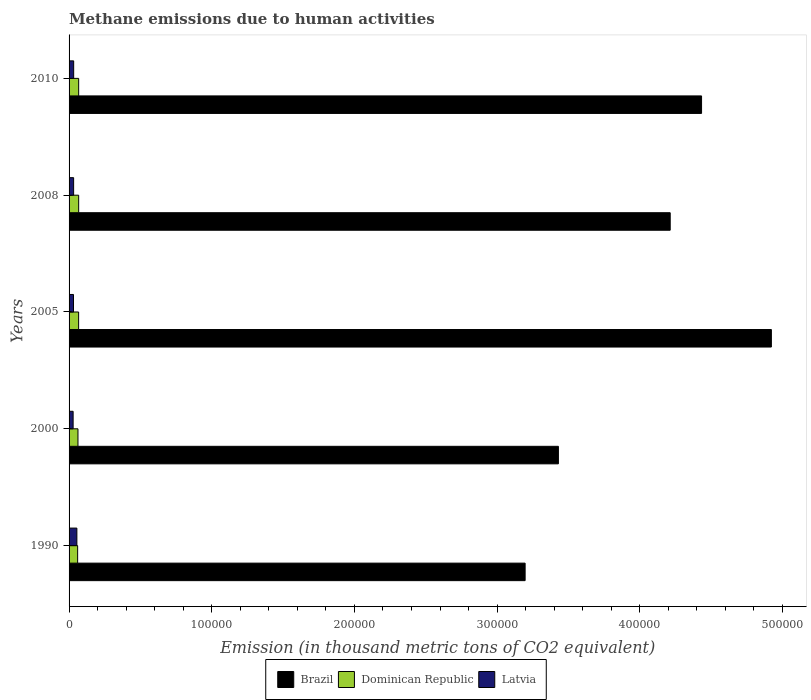Are the number of bars per tick equal to the number of legend labels?
Your answer should be very brief. Yes. What is the amount of methane emitted in Latvia in 2000?
Your response must be concise. 2840. Across all years, what is the maximum amount of methane emitted in Latvia?
Give a very brief answer. 5472.8. Across all years, what is the minimum amount of methane emitted in Brazil?
Ensure brevity in your answer.  3.20e+05. In which year was the amount of methane emitted in Dominican Republic minimum?
Provide a succinct answer. 1990. What is the total amount of methane emitted in Brazil in the graph?
Your response must be concise. 2.02e+06. What is the difference between the amount of methane emitted in Dominican Republic in 2000 and that in 2005?
Give a very brief answer. -456. What is the difference between the amount of methane emitted in Brazil in 1990 and the amount of methane emitted in Dominican Republic in 2008?
Your response must be concise. 3.13e+05. What is the average amount of methane emitted in Dominican Republic per year?
Make the answer very short. 6479.88. In the year 2000, what is the difference between the amount of methane emitted in Brazil and amount of methane emitted in Dominican Republic?
Your answer should be very brief. 3.37e+05. In how many years, is the amount of methane emitted in Brazil greater than 220000 thousand metric tons?
Your answer should be very brief. 5. What is the ratio of the amount of methane emitted in Dominican Republic in 2000 to that in 2010?
Give a very brief answer. 0.93. Is the amount of methane emitted in Brazil in 2005 less than that in 2010?
Ensure brevity in your answer.  No. Is the difference between the amount of methane emitted in Brazil in 2000 and 2008 greater than the difference between the amount of methane emitted in Dominican Republic in 2000 and 2008?
Your answer should be compact. No. What is the difference between the highest and the second highest amount of methane emitted in Brazil?
Offer a very short reply. 4.89e+04. What is the difference between the highest and the lowest amount of methane emitted in Latvia?
Make the answer very short. 2632.8. What does the 2nd bar from the top in 2000 represents?
Ensure brevity in your answer.  Dominican Republic. What does the 2nd bar from the bottom in 2000 represents?
Provide a short and direct response. Dominican Republic. How many years are there in the graph?
Make the answer very short. 5. Are the values on the major ticks of X-axis written in scientific E-notation?
Ensure brevity in your answer.  No. Does the graph contain any zero values?
Offer a very short reply. No. Does the graph contain grids?
Your answer should be compact. No. Where does the legend appear in the graph?
Make the answer very short. Bottom center. How many legend labels are there?
Your response must be concise. 3. What is the title of the graph?
Give a very brief answer. Methane emissions due to human activities. Does "Channel Islands" appear as one of the legend labels in the graph?
Your response must be concise. No. What is the label or title of the X-axis?
Ensure brevity in your answer.  Emission (in thousand metric tons of CO2 equivalent). What is the Emission (in thousand metric tons of CO2 equivalent) of Brazil in 1990?
Your response must be concise. 3.20e+05. What is the Emission (in thousand metric tons of CO2 equivalent) of Dominican Republic in 1990?
Make the answer very short. 6003.8. What is the Emission (in thousand metric tons of CO2 equivalent) of Latvia in 1990?
Ensure brevity in your answer.  5472.8. What is the Emission (in thousand metric tons of CO2 equivalent) of Brazil in 2000?
Provide a short and direct response. 3.43e+05. What is the Emission (in thousand metric tons of CO2 equivalent) in Dominican Republic in 2000?
Your answer should be compact. 6238.7. What is the Emission (in thousand metric tons of CO2 equivalent) in Latvia in 2000?
Make the answer very short. 2840. What is the Emission (in thousand metric tons of CO2 equivalent) of Brazil in 2005?
Keep it short and to the point. 4.92e+05. What is the Emission (in thousand metric tons of CO2 equivalent) of Dominican Republic in 2005?
Your answer should be very brief. 6694.7. What is the Emission (in thousand metric tons of CO2 equivalent) in Latvia in 2005?
Your response must be concise. 3105. What is the Emission (in thousand metric tons of CO2 equivalent) of Brazil in 2008?
Make the answer very short. 4.21e+05. What is the Emission (in thousand metric tons of CO2 equivalent) in Dominican Republic in 2008?
Give a very brief answer. 6733.1. What is the Emission (in thousand metric tons of CO2 equivalent) of Latvia in 2008?
Your answer should be compact. 3192.1. What is the Emission (in thousand metric tons of CO2 equivalent) of Brazil in 2010?
Offer a very short reply. 4.43e+05. What is the Emission (in thousand metric tons of CO2 equivalent) of Dominican Republic in 2010?
Offer a terse response. 6729.1. What is the Emission (in thousand metric tons of CO2 equivalent) in Latvia in 2010?
Your response must be concise. 3227.4. Across all years, what is the maximum Emission (in thousand metric tons of CO2 equivalent) of Brazil?
Make the answer very short. 4.92e+05. Across all years, what is the maximum Emission (in thousand metric tons of CO2 equivalent) in Dominican Republic?
Offer a very short reply. 6733.1. Across all years, what is the maximum Emission (in thousand metric tons of CO2 equivalent) in Latvia?
Provide a short and direct response. 5472.8. Across all years, what is the minimum Emission (in thousand metric tons of CO2 equivalent) in Brazil?
Give a very brief answer. 3.20e+05. Across all years, what is the minimum Emission (in thousand metric tons of CO2 equivalent) in Dominican Republic?
Your answer should be compact. 6003.8. Across all years, what is the minimum Emission (in thousand metric tons of CO2 equivalent) of Latvia?
Provide a short and direct response. 2840. What is the total Emission (in thousand metric tons of CO2 equivalent) in Brazil in the graph?
Provide a succinct answer. 2.02e+06. What is the total Emission (in thousand metric tons of CO2 equivalent) of Dominican Republic in the graph?
Offer a very short reply. 3.24e+04. What is the total Emission (in thousand metric tons of CO2 equivalent) in Latvia in the graph?
Your answer should be very brief. 1.78e+04. What is the difference between the Emission (in thousand metric tons of CO2 equivalent) in Brazil in 1990 and that in 2000?
Give a very brief answer. -2.33e+04. What is the difference between the Emission (in thousand metric tons of CO2 equivalent) in Dominican Republic in 1990 and that in 2000?
Offer a very short reply. -234.9. What is the difference between the Emission (in thousand metric tons of CO2 equivalent) of Latvia in 1990 and that in 2000?
Ensure brevity in your answer.  2632.8. What is the difference between the Emission (in thousand metric tons of CO2 equivalent) of Brazil in 1990 and that in 2005?
Your response must be concise. -1.73e+05. What is the difference between the Emission (in thousand metric tons of CO2 equivalent) in Dominican Republic in 1990 and that in 2005?
Provide a succinct answer. -690.9. What is the difference between the Emission (in thousand metric tons of CO2 equivalent) in Latvia in 1990 and that in 2005?
Give a very brief answer. 2367.8. What is the difference between the Emission (in thousand metric tons of CO2 equivalent) in Brazil in 1990 and that in 2008?
Provide a short and direct response. -1.02e+05. What is the difference between the Emission (in thousand metric tons of CO2 equivalent) in Dominican Republic in 1990 and that in 2008?
Make the answer very short. -729.3. What is the difference between the Emission (in thousand metric tons of CO2 equivalent) of Latvia in 1990 and that in 2008?
Offer a very short reply. 2280.7. What is the difference between the Emission (in thousand metric tons of CO2 equivalent) of Brazil in 1990 and that in 2010?
Your answer should be very brief. -1.24e+05. What is the difference between the Emission (in thousand metric tons of CO2 equivalent) of Dominican Republic in 1990 and that in 2010?
Offer a terse response. -725.3. What is the difference between the Emission (in thousand metric tons of CO2 equivalent) in Latvia in 1990 and that in 2010?
Give a very brief answer. 2245.4. What is the difference between the Emission (in thousand metric tons of CO2 equivalent) in Brazil in 2000 and that in 2005?
Give a very brief answer. -1.49e+05. What is the difference between the Emission (in thousand metric tons of CO2 equivalent) of Dominican Republic in 2000 and that in 2005?
Make the answer very short. -456. What is the difference between the Emission (in thousand metric tons of CO2 equivalent) of Latvia in 2000 and that in 2005?
Provide a succinct answer. -265. What is the difference between the Emission (in thousand metric tons of CO2 equivalent) in Brazil in 2000 and that in 2008?
Ensure brevity in your answer.  -7.84e+04. What is the difference between the Emission (in thousand metric tons of CO2 equivalent) in Dominican Republic in 2000 and that in 2008?
Your answer should be very brief. -494.4. What is the difference between the Emission (in thousand metric tons of CO2 equivalent) of Latvia in 2000 and that in 2008?
Give a very brief answer. -352.1. What is the difference between the Emission (in thousand metric tons of CO2 equivalent) of Brazil in 2000 and that in 2010?
Your answer should be very brief. -1.00e+05. What is the difference between the Emission (in thousand metric tons of CO2 equivalent) in Dominican Republic in 2000 and that in 2010?
Provide a short and direct response. -490.4. What is the difference between the Emission (in thousand metric tons of CO2 equivalent) in Latvia in 2000 and that in 2010?
Make the answer very short. -387.4. What is the difference between the Emission (in thousand metric tons of CO2 equivalent) of Brazil in 2005 and that in 2008?
Give a very brief answer. 7.09e+04. What is the difference between the Emission (in thousand metric tons of CO2 equivalent) of Dominican Republic in 2005 and that in 2008?
Your answer should be very brief. -38.4. What is the difference between the Emission (in thousand metric tons of CO2 equivalent) of Latvia in 2005 and that in 2008?
Offer a terse response. -87.1. What is the difference between the Emission (in thousand metric tons of CO2 equivalent) of Brazil in 2005 and that in 2010?
Offer a very short reply. 4.89e+04. What is the difference between the Emission (in thousand metric tons of CO2 equivalent) of Dominican Republic in 2005 and that in 2010?
Your answer should be compact. -34.4. What is the difference between the Emission (in thousand metric tons of CO2 equivalent) in Latvia in 2005 and that in 2010?
Offer a terse response. -122.4. What is the difference between the Emission (in thousand metric tons of CO2 equivalent) in Brazil in 2008 and that in 2010?
Ensure brevity in your answer.  -2.20e+04. What is the difference between the Emission (in thousand metric tons of CO2 equivalent) of Latvia in 2008 and that in 2010?
Keep it short and to the point. -35.3. What is the difference between the Emission (in thousand metric tons of CO2 equivalent) of Brazil in 1990 and the Emission (in thousand metric tons of CO2 equivalent) of Dominican Republic in 2000?
Your answer should be compact. 3.13e+05. What is the difference between the Emission (in thousand metric tons of CO2 equivalent) of Brazil in 1990 and the Emission (in thousand metric tons of CO2 equivalent) of Latvia in 2000?
Provide a succinct answer. 3.17e+05. What is the difference between the Emission (in thousand metric tons of CO2 equivalent) of Dominican Republic in 1990 and the Emission (in thousand metric tons of CO2 equivalent) of Latvia in 2000?
Keep it short and to the point. 3163.8. What is the difference between the Emission (in thousand metric tons of CO2 equivalent) of Brazil in 1990 and the Emission (in thousand metric tons of CO2 equivalent) of Dominican Republic in 2005?
Ensure brevity in your answer.  3.13e+05. What is the difference between the Emission (in thousand metric tons of CO2 equivalent) in Brazil in 1990 and the Emission (in thousand metric tons of CO2 equivalent) in Latvia in 2005?
Make the answer very short. 3.17e+05. What is the difference between the Emission (in thousand metric tons of CO2 equivalent) of Dominican Republic in 1990 and the Emission (in thousand metric tons of CO2 equivalent) of Latvia in 2005?
Give a very brief answer. 2898.8. What is the difference between the Emission (in thousand metric tons of CO2 equivalent) in Brazil in 1990 and the Emission (in thousand metric tons of CO2 equivalent) in Dominican Republic in 2008?
Make the answer very short. 3.13e+05. What is the difference between the Emission (in thousand metric tons of CO2 equivalent) of Brazil in 1990 and the Emission (in thousand metric tons of CO2 equivalent) of Latvia in 2008?
Give a very brief answer. 3.16e+05. What is the difference between the Emission (in thousand metric tons of CO2 equivalent) in Dominican Republic in 1990 and the Emission (in thousand metric tons of CO2 equivalent) in Latvia in 2008?
Offer a very short reply. 2811.7. What is the difference between the Emission (in thousand metric tons of CO2 equivalent) in Brazil in 1990 and the Emission (in thousand metric tons of CO2 equivalent) in Dominican Republic in 2010?
Your answer should be very brief. 3.13e+05. What is the difference between the Emission (in thousand metric tons of CO2 equivalent) in Brazil in 1990 and the Emission (in thousand metric tons of CO2 equivalent) in Latvia in 2010?
Provide a short and direct response. 3.16e+05. What is the difference between the Emission (in thousand metric tons of CO2 equivalent) in Dominican Republic in 1990 and the Emission (in thousand metric tons of CO2 equivalent) in Latvia in 2010?
Offer a terse response. 2776.4. What is the difference between the Emission (in thousand metric tons of CO2 equivalent) in Brazil in 2000 and the Emission (in thousand metric tons of CO2 equivalent) in Dominican Republic in 2005?
Your answer should be very brief. 3.36e+05. What is the difference between the Emission (in thousand metric tons of CO2 equivalent) of Brazil in 2000 and the Emission (in thousand metric tons of CO2 equivalent) of Latvia in 2005?
Provide a short and direct response. 3.40e+05. What is the difference between the Emission (in thousand metric tons of CO2 equivalent) of Dominican Republic in 2000 and the Emission (in thousand metric tons of CO2 equivalent) of Latvia in 2005?
Your response must be concise. 3133.7. What is the difference between the Emission (in thousand metric tons of CO2 equivalent) of Brazil in 2000 and the Emission (in thousand metric tons of CO2 equivalent) of Dominican Republic in 2008?
Provide a succinct answer. 3.36e+05. What is the difference between the Emission (in thousand metric tons of CO2 equivalent) of Brazil in 2000 and the Emission (in thousand metric tons of CO2 equivalent) of Latvia in 2008?
Give a very brief answer. 3.40e+05. What is the difference between the Emission (in thousand metric tons of CO2 equivalent) of Dominican Republic in 2000 and the Emission (in thousand metric tons of CO2 equivalent) of Latvia in 2008?
Make the answer very short. 3046.6. What is the difference between the Emission (in thousand metric tons of CO2 equivalent) in Brazil in 2000 and the Emission (in thousand metric tons of CO2 equivalent) in Dominican Republic in 2010?
Provide a succinct answer. 3.36e+05. What is the difference between the Emission (in thousand metric tons of CO2 equivalent) in Brazil in 2000 and the Emission (in thousand metric tons of CO2 equivalent) in Latvia in 2010?
Keep it short and to the point. 3.40e+05. What is the difference between the Emission (in thousand metric tons of CO2 equivalent) of Dominican Republic in 2000 and the Emission (in thousand metric tons of CO2 equivalent) of Latvia in 2010?
Keep it short and to the point. 3011.3. What is the difference between the Emission (in thousand metric tons of CO2 equivalent) in Brazil in 2005 and the Emission (in thousand metric tons of CO2 equivalent) in Dominican Republic in 2008?
Make the answer very short. 4.85e+05. What is the difference between the Emission (in thousand metric tons of CO2 equivalent) of Brazil in 2005 and the Emission (in thousand metric tons of CO2 equivalent) of Latvia in 2008?
Make the answer very short. 4.89e+05. What is the difference between the Emission (in thousand metric tons of CO2 equivalent) in Dominican Republic in 2005 and the Emission (in thousand metric tons of CO2 equivalent) in Latvia in 2008?
Offer a very short reply. 3502.6. What is the difference between the Emission (in thousand metric tons of CO2 equivalent) of Brazil in 2005 and the Emission (in thousand metric tons of CO2 equivalent) of Dominican Republic in 2010?
Ensure brevity in your answer.  4.85e+05. What is the difference between the Emission (in thousand metric tons of CO2 equivalent) of Brazil in 2005 and the Emission (in thousand metric tons of CO2 equivalent) of Latvia in 2010?
Provide a short and direct response. 4.89e+05. What is the difference between the Emission (in thousand metric tons of CO2 equivalent) of Dominican Republic in 2005 and the Emission (in thousand metric tons of CO2 equivalent) of Latvia in 2010?
Keep it short and to the point. 3467.3. What is the difference between the Emission (in thousand metric tons of CO2 equivalent) of Brazil in 2008 and the Emission (in thousand metric tons of CO2 equivalent) of Dominican Republic in 2010?
Make the answer very short. 4.15e+05. What is the difference between the Emission (in thousand metric tons of CO2 equivalent) in Brazil in 2008 and the Emission (in thousand metric tons of CO2 equivalent) in Latvia in 2010?
Your response must be concise. 4.18e+05. What is the difference between the Emission (in thousand metric tons of CO2 equivalent) of Dominican Republic in 2008 and the Emission (in thousand metric tons of CO2 equivalent) of Latvia in 2010?
Give a very brief answer. 3505.7. What is the average Emission (in thousand metric tons of CO2 equivalent) in Brazil per year?
Provide a succinct answer. 4.04e+05. What is the average Emission (in thousand metric tons of CO2 equivalent) in Dominican Republic per year?
Your answer should be very brief. 6479.88. What is the average Emission (in thousand metric tons of CO2 equivalent) of Latvia per year?
Offer a terse response. 3567.46. In the year 1990, what is the difference between the Emission (in thousand metric tons of CO2 equivalent) in Brazil and Emission (in thousand metric tons of CO2 equivalent) in Dominican Republic?
Keep it short and to the point. 3.14e+05. In the year 1990, what is the difference between the Emission (in thousand metric tons of CO2 equivalent) of Brazil and Emission (in thousand metric tons of CO2 equivalent) of Latvia?
Ensure brevity in your answer.  3.14e+05. In the year 1990, what is the difference between the Emission (in thousand metric tons of CO2 equivalent) in Dominican Republic and Emission (in thousand metric tons of CO2 equivalent) in Latvia?
Your answer should be very brief. 531. In the year 2000, what is the difference between the Emission (in thousand metric tons of CO2 equivalent) in Brazil and Emission (in thousand metric tons of CO2 equivalent) in Dominican Republic?
Offer a terse response. 3.37e+05. In the year 2000, what is the difference between the Emission (in thousand metric tons of CO2 equivalent) of Brazil and Emission (in thousand metric tons of CO2 equivalent) of Latvia?
Your answer should be very brief. 3.40e+05. In the year 2000, what is the difference between the Emission (in thousand metric tons of CO2 equivalent) of Dominican Republic and Emission (in thousand metric tons of CO2 equivalent) of Latvia?
Your answer should be compact. 3398.7. In the year 2005, what is the difference between the Emission (in thousand metric tons of CO2 equivalent) of Brazil and Emission (in thousand metric tons of CO2 equivalent) of Dominican Republic?
Offer a terse response. 4.86e+05. In the year 2005, what is the difference between the Emission (in thousand metric tons of CO2 equivalent) of Brazil and Emission (in thousand metric tons of CO2 equivalent) of Latvia?
Ensure brevity in your answer.  4.89e+05. In the year 2005, what is the difference between the Emission (in thousand metric tons of CO2 equivalent) of Dominican Republic and Emission (in thousand metric tons of CO2 equivalent) of Latvia?
Keep it short and to the point. 3589.7. In the year 2008, what is the difference between the Emission (in thousand metric tons of CO2 equivalent) of Brazil and Emission (in thousand metric tons of CO2 equivalent) of Dominican Republic?
Your answer should be compact. 4.15e+05. In the year 2008, what is the difference between the Emission (in thousand metric tons of CO2 equivalent) in Brazil and Emission (in thousand metric tons of CO2 equivalent) in Latvia?
Give a very brief answer. 4.18e+05. In the year 2008, what is the difference between the Emission (in thousand metric tons of CO2 equivalent) in Dominican Republic and Emission (in thousand metric tons of CO2 equivalent) in Latvia?
Keep it short and to the point. 3541. In the year 2010, what is the difference between the Emission (in thousand metric tons of CO2 equivalent) of Brazil and Emission (in thousand metric tons of CO2 equivalent) of Dominican Republic?
Make the answer very short. 4.37e+05. In the year 2010, what is the difference between the Emission (in thousand metric tons of CO2 equivalent) of Brazil and Emission (in thousand metric tons of CO2 equivalent) of Latvia?
Your answer should be compact. 4.40e+05. In the year 2010, what is the difference between the Emission (in thousand metric tons of CO2 equivalent) in Dominican Republic and Emission (in thousand metric tons of CO2 equivalent) in Latvia?
Offer a terse response. 3501.7. What is the ratio of the Emission (in thousand metric tons of CO2 equivalent) of Brazil in 1990 to that in 2000?
Offer a very short reply. 0.93. What is the ratio of the Emission (in thousand metric tons of CO2 equivalent) in Dominican Republic in 1990 to that in 2000?
Ensure brevity in your answer.  0.96. What is the ratio of the Emission (in thousand metric tons of CO2 equivalent) of Latvia in 1990 to that in 2000?
Keep it short and to the point. 1.93. What is the ratio of the Emission (in thousand metric tons of CO2 equivalent) in Brazil in 1990 to that in 2005?
Provide a short and direct response. 0.65. What is the ratio of the Emission (in thousand metric tons of CO2 equivalent) of Dominican Republic in 1990 to that in 2005?
Offer a terse response. 0.9. What is the ratio of the Emission (in thousand metric tons of CO2 equivalent) in Latvia in 1990 to that in 2005?
Offer a terse response. 1.76. What is the ratio of the Emission (in thousand metric tons of CO2 equivalent) in Brazil in 1990 to that in 2008?
Provide a succinct answer. 0.76. What is the ratio of the Emission (in thousand metric tons of CO2 equivalent) of Dominican Republic in 1990 to that in 2008?
Provide a succinct answer. 0.89. What is the ratio of the Emission (in thousand metric tons of CO2 equivalent) of Latvia in 1990 to that in 2008?
Your answer should be very brief. 1.71. What is the ratio of the Emission (in thousand metric tons of CO2 equivalent) of Brazil in 1990 to that in 2010?
Offer a very short reply. 0.72. What is the ratio of the Emission (in thousand metric tons of CO2 equivalent) in Dominican Republic in 1990 to that in 2010?
Your answer should be very brief. 0.89. What is the ratio of the Emission (in thousand metric tons of CO2 equivalent) in Latvia in 1990 to that in 2010?
Offer a very short reply. 1.7. What is the ratio of the Emission (in thousand metric tons of CO2 equivalent) of Brazil in 2000 to that in 2005?
Make the answer very short. 0.7. What is the ratio of the Emission (in thousand metric tons of CO2 equivalent) in Dominican Republic in 2000 to that in 2005?
Keep it short and to the point. 0.93. What is the ratio of the Emission (in thousand metric tons of CO2 equivalent) of Latvia in 2000 to that in 2005?
Your response must be concise. 0.91. What is the ratio of the Emission (in thousand metric tons of CO2 equivalent) in Brazil in 2000 to that in 2008?
Your answer should be very brief. 0.81. What is the ratio of the Emission (in thousand metric tons of CO2 equivalent) of Dominican Republic in 2000 to that in 2008?
Your response must be concise. 0.93. What is the ratio of the Emission (in thousand metric tons of CO2 equivalent) of Latvia in 2000 to that in 2008?
Your response must be concise. 0.89. What is the ratio of the Emission (in thousand metric tons of CO2 equivalent) in Brazil in 2000 to that in 2010?
Make the answer very short. 0.77. What is the ratio of the Emission (in thousand metric tons of CO2 equivalent) in Dominican Republic in 2000 to that in 2010?
Give a very brief answer. 0.93. What is the ratio of the Emission (in thousand metric tons of CO2 equivalent) in Latvia in 2000 to that in 2010?
Keep it short and to the point. 0.88. What is the ratio of the Emission (in thousand metric tons of CO2 equivalent) in Brazil in 2005 to that in 2008?
Make the answer very short. 1.17. What is the ratio of the Emission (in thousand metric tons of CO2 equivalent) of Latvia in 2005 to that in 2008?
Offer a terse response. 0.97. What is the ratio of the Emission (in thousand metric tons of CO2 equivalent) in Brazil in 2005 to that in 2010?
Your answer should be very brief. 1.11. What is the ratio of the Emission (in thousand metric tons of CO2 equivalent) of Dominican Republic in 2005 to that in 2010?
Give a very brief answer. 0.99. What is the ratio of the Emission (in thousand metric tons of CO2 equivalent) in Latvia in 2005 to that in 2010?
Offer a terse response. 0.96. What is the ratio of the Emission (in thousand metric tons of CO2 equivalent) of Brazil in 2008 to that in 2010?
Offer a terse response. 0.95. What is the difference between the highest and the second highest Emission (in thousand metric tons of CO2 equivalent) of Brazil?
Keep it short and to the point. 4.89e+04. What is the difference between the highest and the second highest Emission (in thousand metric tons of CO2 equivalent) of Dominican Republic?
Offer a very short reply. 4. What is the difference between the highest and the second highest Emission (in thousand metric tons of CO2 equivalent) of Latvia?
Your answer should be very brief. 2245.4. What is the difference between the highest and the lowest Emission (in thousand metric tons of CO2 equivalent) of Brazil?
Provide a short and direct response. 1.73e+05. What is the difference between the highest and the lowest Emission (in thousand metric tons of CO2 equivalent) in Dominican Republic?
Offer a terse response. 729.3. What is the difference between the highest and the lowest Emission (in thousand metric tons of CO2 equivalent) in Latvia?
Provide a short and direct response. 2632.8. 